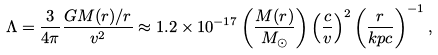<formula> <loc_0><loc_0><loc_500><loc_500>\Lambda = \frac { 3 } { 4 \pi } \frac { G M ( r ) / r } { v ^ { 2 } } \approx 1 . 2 \times 1 0 ^ { - 1 7 } \left ( \frac { M ( r ) } { M _ { \odot } } \right ) \left ( \frac { c } { v } \right ) ^ { 2 } \left ( \frac { r } { k p c } \right ) ^ { - 1 } ,</formula> 